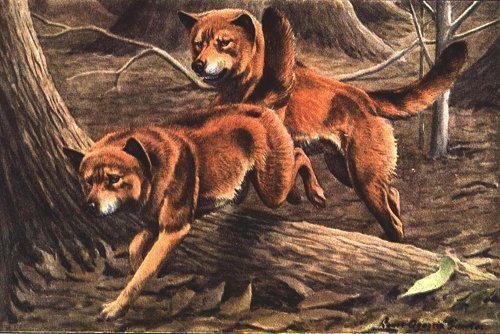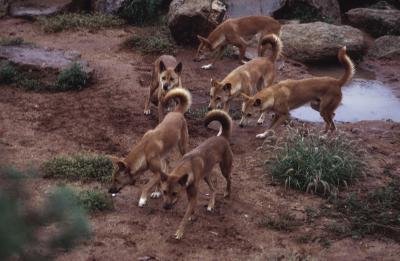The first image is the image on the left, the second image is the image on the right. For the images displayed, is the sentence "There are no more than two dingo's in the right image." factually correct? Answer yes or no. No. 